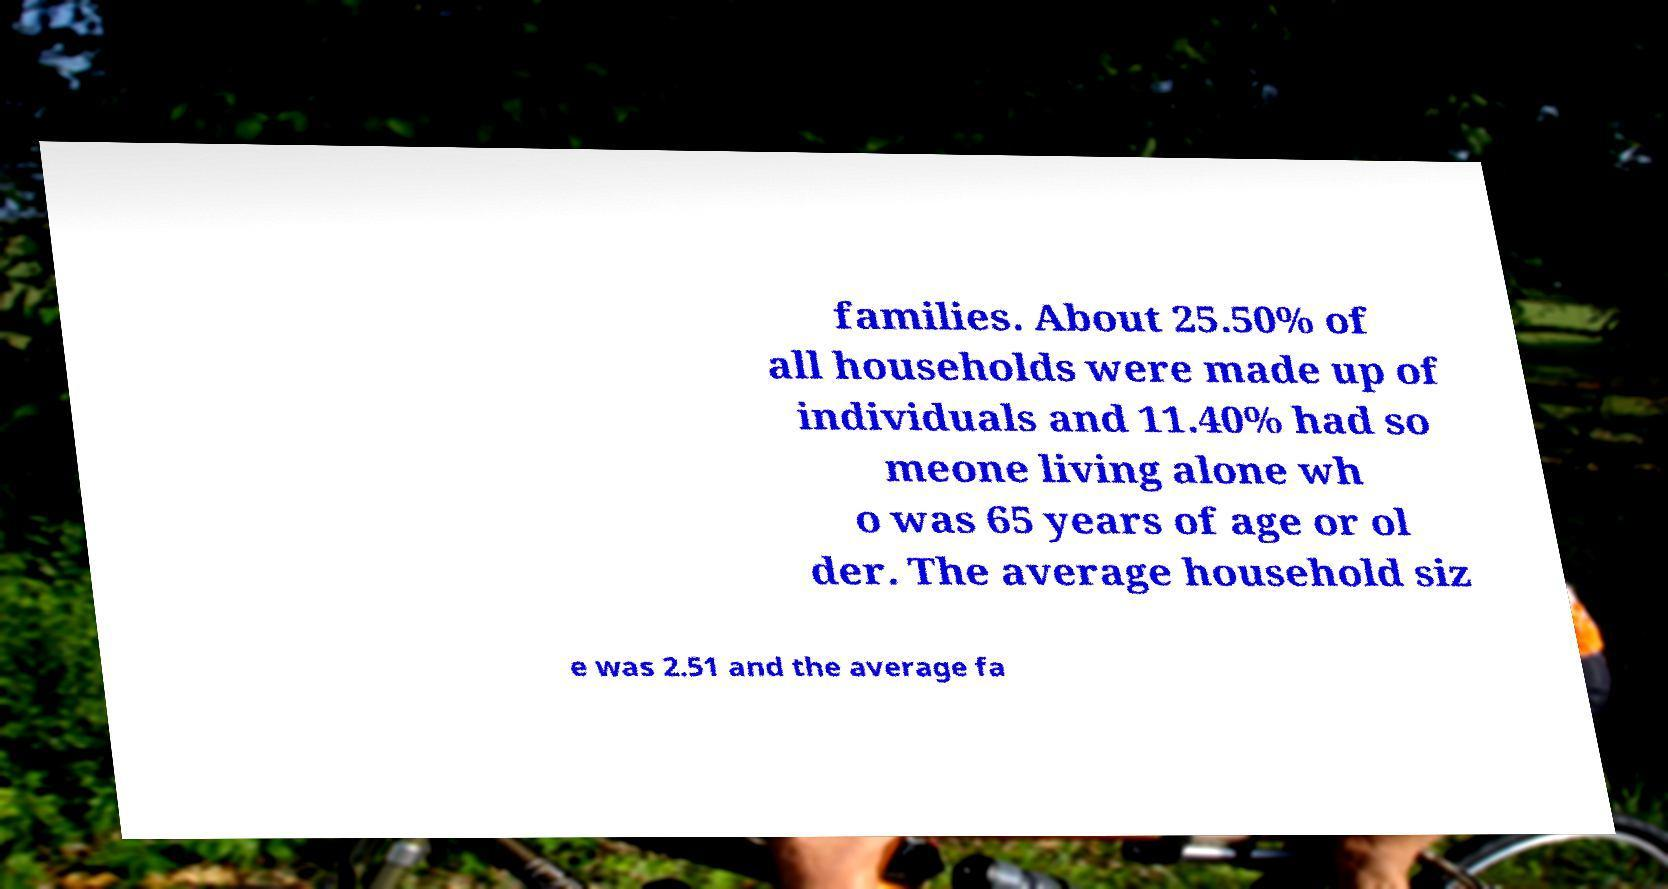There's text embedded in this image that I need extracted. Can you transcribe it verbatim? families. About 25.50% of all households were made up of individuals and 11.40% had so meone living alone wh o was 65 years of age or ol der. The average household siz e was 2.51 and the average fa 